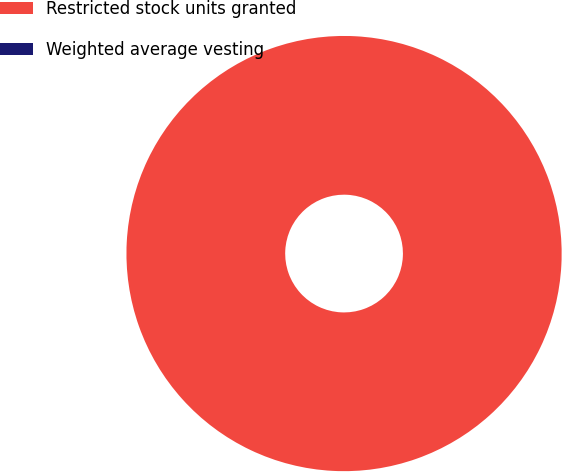Convert chart. <chart><loc_0><loc_0><loc_500><loc_500><pie_chart><fcel>Restricted stock units granted<fcel>Weighted average vesting<nl><fcel>100.0%<fcel>0.0%<nl></chart> 